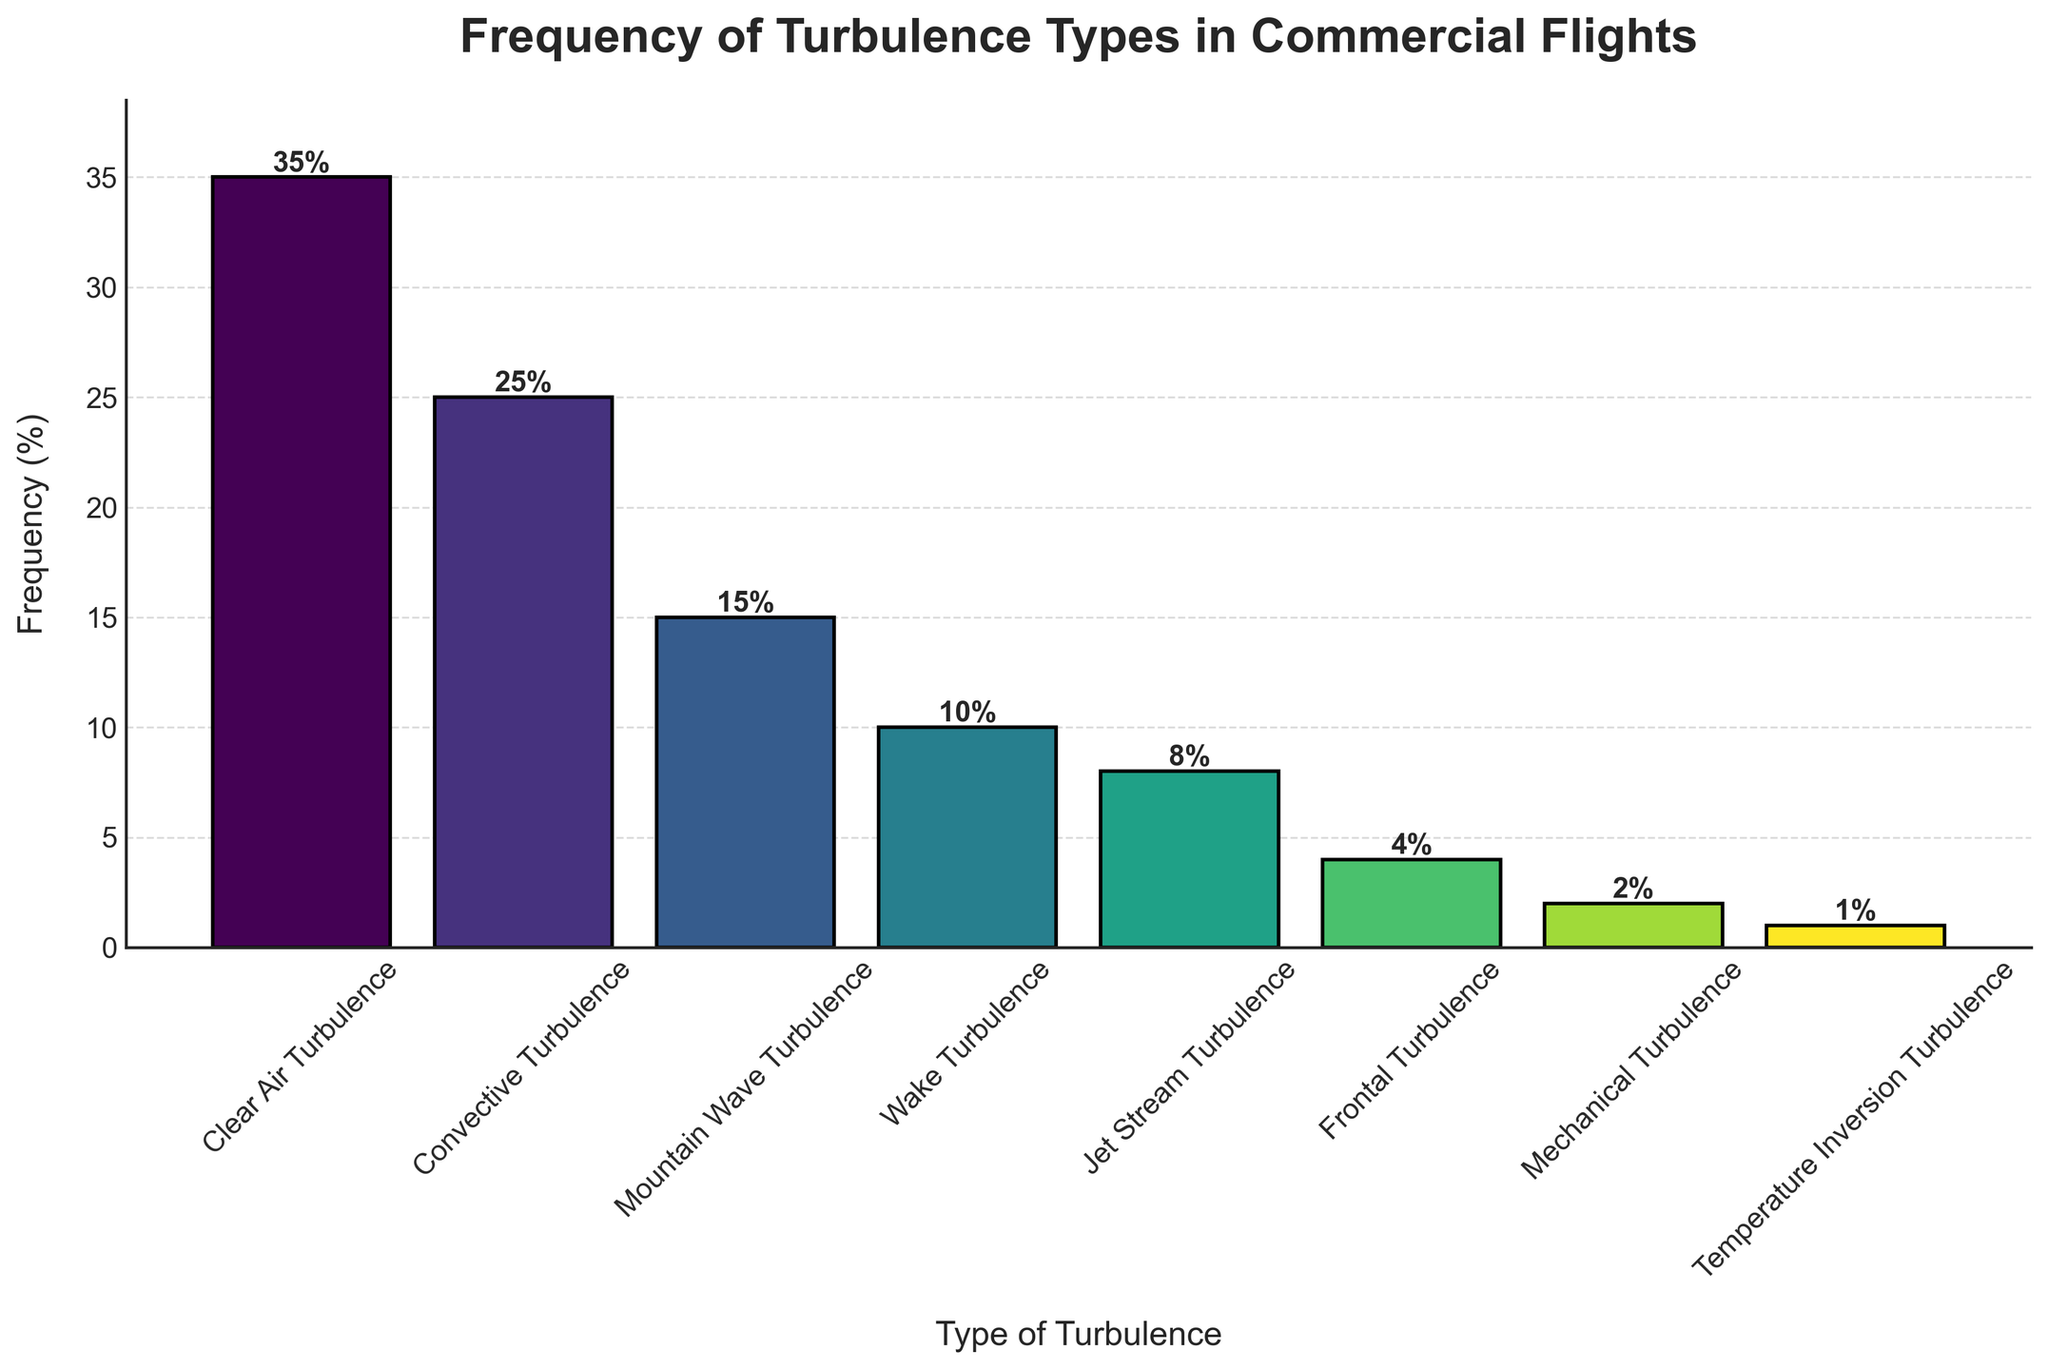What type of turbulence is encountered most frequently? Looking at the height of the bars, the tallest bar represents Clear Air Turbulence with a frequency of 35%.
Answer: Clear Air Turbulence Which type of turbulence is the least common? The shortest bar represents Temperature Inversion Turbulence with a frequency of 1%.
Answer: Temperature Inversion Turbulence What is the total frequency of Convective Turbulence and Mountain Wave Turbulence? From the bar chart, Convective Turbulence is 25% and Mountain Wave Turbulence is 15%. Summing them up, 25% + 15% = 40%.
Answer: 40% Is Jet Stream Turbulence more common than Wake Turbulence? Comparing the bar heights for Jet Stream Turbulence (8%) and Wake Turbulence (10%), Wake Turbulence is taller. Hence, Jet Stream Turbulence is less common.
Answer: No, Wake Turbulence is more common How much more frequent is Clear Air Turbulence compared to Frontal Turbulence? Clear Air Turbulence has a frequency of 35% and Frontal Turbulence has a frequency of 4%. The difference is 35% - 4% = 31%.
Answer: 31% What is the average frequency of Mechanical Turbulence and Temperature Inversion Turbulence? Mechanical Turbulence is 2% and Temperature Inversion Turbulence is 1%; therefore, the average is (2% + 1%) / 2 = 1.5%.
Answer: 1.5% Between Clear Air Turbulence and Jet Stream Turbulence, which one is more frequent, and by how much? Clear Air Turbulence is 35% and Jet Stream Turbulence is 8%. The difference is 35% - 8% = 27%. So, Clear Air Turbulence is more frequent by 27%.
Answer: Clear Air Turbulence by 27% Is the total frequency of Wake Turbulence, Jet Stream Turbulence, and Frontal Turbulence greater than Convective Turbulence alone? Summing the frequencies of Wake Turbulence (10%), Jet Stream Turbulence (8%), and Frontal Turbulence (4%) gives 10% + 8% + 4% = 22%. Convective Turbulence is 25%. Hence, 22% < 25%.
Answer: No What percentage of turbulence types occur 10% or more frequently? Clear Air Turbulence (35%), Convective Turbulence (25%), Mountain Wave Turbulence (15%), and Wake Turbulence (10%) all meet this criterion. Adding these, we get 4 types.
Answer: 4 types 